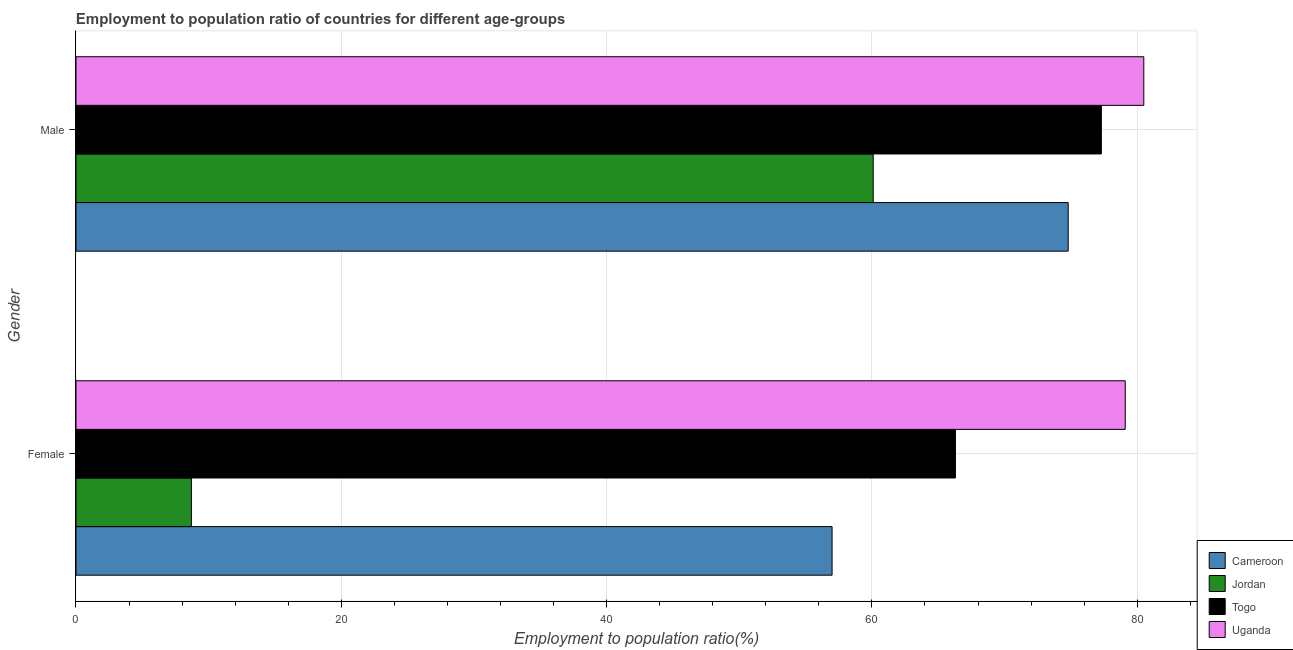What is the label of the 1st group of bars from the top?
Keep it short and to the point. Male. What is the employment to population ratio(male) in Uganda?
Offer a terse response. 80.5. Across all countries, what is the maximum employment to population ratio(female)?
Make the answer very short. 79.1. Across all countries, what is the minimum employment to population ratio(female)?
Provide a short and direct response. 8.7. In which country was the employment to population ratio(male) maximum?
Offer a very short reply. Uganda. In which country was the employment to population ratio(male) minimum?
Give a very brief answer. Jordan. What is the total employment to population ratio(male) in the graph?
Provide a succinct answer. 292.7. What is the difference between the employment to population ratio(female) in Cameroon and that in Uganda?
Make the answer very short. -22.1. What is the difference between the employment to population ratio(male) in Jordan and the employment to population ratio(female) in Togo?
Ensure brevity in your answer.  -6.2. What is the average employment to population ratio(female) per country?
Offer a terse response. 52.78. What is the difference between the employment to population ratio(female) and employment to population ratio(male) in Togo?
Your response must be concise. -11. In how many countries, is the employment to population ratio(male) greater than 40 %?
Keep it short and to the point. 4. What is the ratio of the employment to population ratio(male) in Uganda to that in Cameroon?
Provide a succinct answer. 1.08. Is the employment to population ratio(male) in Uganda less than that in Togo?
Offer a very short reply. No. In how many countries, is the employment to population ratio(female) greater than the average employment to population ratio(female) taken over all countries?
Your response must be concise. 3. What does the 1st bar from the top in Male represents?
Keep it short and to the point. Uganda. What does the 3rd bar from the bottom in Female represents?
Provide a short and direct response. Togo. How many countries are there in the graph?
Your response must be concise. 4. Does the graph contain any zero values?
Provide a short and direct response. No. Does the graph contain grids?
Keep it short and to the point. Yes. How are the legend labels stacked?
Ensure brevity in your answer.  Vertical. What is the title of the graph?
Provide a short and direct response. Employment to population ratio of countries for different age-groups. What is the label or title of the Y-axis?
Provide a succinct answer. Gender. What is the Employment to population ratio(%) of Jordan in Female?
Provide a succinct answer. 8.7. What is the Employment to population ratio(%) in Togo in Female?
Offer a very short reply. 66.3. What is the Employment to population ratio(%) of Uganda in Female?
Your response must be concise. 79.1. What is the Employment to population ratio(%) of Cameroon in Male?
Offer a terse response. 74.8. What is the Employment to population ratio(%) in Jordan in Male?
Make the answer very short. 60.1. What is the Employment to population ratio(%) of Togo in Male?
Offer a very short reply. 77.3. What is the Employment to population ratio(%) in Uganda in Male?
Your answer should be compact. 80.5. Across all Gender, what is the maximum Employment to population ratio(%) in Cameroon?
Offer a very short reply. 74.8. Across all Gender, what is the maximum Employment to population ratio(%) of Jordan?
Offer a terse response. 60.1. Across all Gender, what is the maximum Employment to population ratio(%) in Togo?
Provide a succinct answer. 77.3. Across all Gender, what is the maximum Employment to population ratio(%) in Uganda?
Your answer should be compact. 80.5. Across all Gender, what is the minimum Employment to population ratio(%) in Jordan?
Provide a short and direct response. 8.7. Across all Gender, what is the minimum Employment to population ratio(%) in Togo?
Provide a succinct answer. 66.3. Across all Gender, what is the minimum Employment to population ratio(%) of Uganda?
Make the answer very short. 79.1. What is the total Employment to population ratio(%) in Cameroon in the graph?
Offer a very short reply. 131.8. What is the total Employment to population ratio(%) of Jordan in the graph?
Provide a succinct answer. 68.8. What is the total Employment to population ratio(%) of Togo in the graph?
Your response must be concise. 143.6. What is the total Employment to population ratio(%) in Uganda in the graph?
Keep it short and to the point. 159.6. What is the difference between the Employment to population ratio(%) of Cameroon in Female and that in Male?
Your answer should be very brief. -17.8. What is the difference between the Employment to population ratio(%) in Jordan in Female and that in Male?
Provide a short and direct response. -51.4. What is the difference between the Employment to population ratio(%) of Cameroon in Female and the Employment to population ratio(%) of Togo in Male?
Provide a succinct answer. -20.3. What is the difference between the Employment to population ratio(%) in Cameroon in Female and the Employment to population ratio(%) in Uganda in Male?
Provide a succinct answer. -23.5. What is the difference between the Employment to population ratio(%) in Jordan in Female and the Employment to population ratio(%) in Togo in Male?
Ensure brevity in your answer.  -68.6. What is the difference between the Employment to population ratio(%) of Jordan in Female and the Employment to population ratio(%) of Uganda in Male?
Provide a short and direct response. -71.8. What is the average Employment to population ratio(%) in Cameroon per Gender?
Your answer should be very brief. 65.9. What is the average Employment to population ratio(%) of Jordan per Gender?
Offer a very short reply. 34.4. What is the average Employment to population ratio(%) in Togo per Gender?
Provide a short and direct response. 71.8. What is the average Employment to population ratio(%) in Uganda per Gender?
Give a very brief answer. 79.8. What is the difference between the Employment to population ratio(%) of Cameroon and Employment to population ratio(%) of Jordan in Female?
Offer a terse response. 48.3. What is the difference between the Employment to population ratio(%) of Cameroon and Employment to population ratio(%) of Uganda in Female?
Your response must be concise. -22.1. What is the difference between the Employment to population ratio(%) in Jordan and Employment to population ratio(%) in Togo in Female?
Ensure brevity in your answer.  -57.6. What is the difference between the Employment to population ratio(%) in Jordan and Employment to population ratio(%) in Uganda in Female?
Your response must be concise. -70.4. What is the difference between the Employment to population ratio(%) of Cameroon and Employment to population ratio(%) of Jordan in Male?
Offer a very short reply. 14.7. What is the difference between the Employment to population ratio(%) of Cameroon and Employment to population ratio(%) of Uganda in Male?
Offer a very short reply. -5.7. What is the difference between the Employment to population ratio(%) in Jordan and Employment to population ratio(%) in Togo in Male?
Keep it short and to the point. -17.2. What is the difference between the Employment to population ratio(%) in Jordan and Employment to population ratio(%) in Uganda in Male?
Give a very brief answer. -20.4. What is the difference between the Employment to population ratio(%) of Togo and Employment to population ratio(%) of Uganda in Male?
Provide a succinct answer. -3.2. What is the ratio of the Employment to population ratio(%) of Cameroon in Female to that in Male?
Provide a short and direct response. 0.76. What is the ratio of the Employment to population ratio(%) in Jordan in Female to that in Male?
Keep it short and to the point. 0.14. What is the ratio of the Employment to population ratio(%) in Togo in Female to that in Male?
Your answer should be compact. 0.86. What is the ratio of the Employment to population ratio(%) of Uganda in Female to that in Male?
Give a very brief answer. 0.98. What is the difference between the highest and the second highest Employment to population ratio(%) in Cameroon?
Ensure brevity in your answer.  17.8. What is the difference between the highest and the second highest Employment to population ratio(%) in Jordan?
Make the answer very short. 51.4. What is the difference between the highest and the lowest Employment to population ratio(%) of Cameroon?
Your answer should be compact. 17.8. What is the difference between the highest and the lowest Employment to population ratio(%) of Jordan?
Your answer should be very brief. 51.4. What is the difference between the highest and the lowest Employment to population ratio(%) in Togo?
Give a very brief answer. 11. What is the difference between the highest and the lowest Employment to population ratio(%) in Uganda?
Your response must be concise. 1.4. 